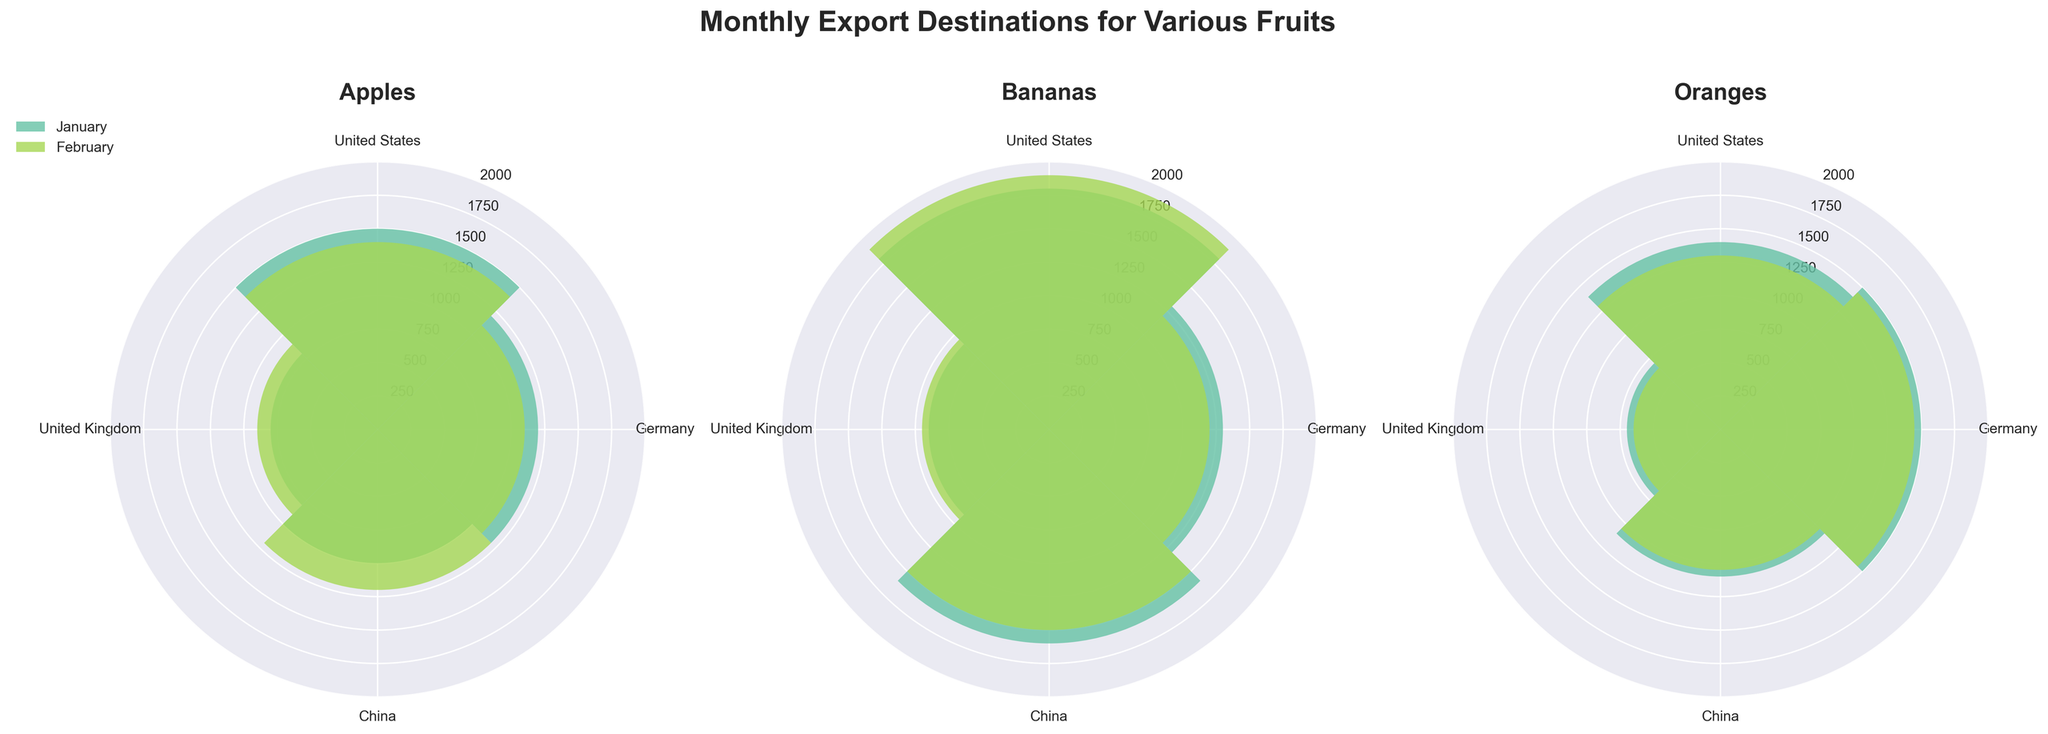What fruit has the highest export quantity to the United States in January? Look at the 'United States' sections of the rose charts for each fruit and compare their heights. Bananas have the tallest bar in the United States section in January.
Answer: Bananas Which export destination received the least amount of oranges in February? Look at the 'Oranges' rose chart and compare the heights of the February bars. The shortest bar is at 'United Kingdom.'
Answer: United Kingdom How does the quantity of apples exported to China change from January to February? Look at the 'Apples' rose chart and compare the length of the bars for China in January and February. January's bar extends to 1000, and February's extends to 1200. The difference is 200 metric tons.
Answer: Increases by 200 metric tons Which month had a higher total export quantity for apples, January or February? Add up the quantities of apples for all destinations in January and February by locating and summing the respective bars. January: 1500 + 1200 + 1000 + 800 = 4500. February: 1400 + 1100 + 1200 + 900 = 4600.
Answer: February Between Germany and the United Kingdom, which received more bananas in January? Compare the height of the bars for 'Bananas' and the export destinations 'Germany' and 'United Kingdom' in January. Germany's bar is taller than the United Kingdom's bar in January.
Answer: Germany What is the average export quantity of oranges to all destinations in February? Look at the 'Oranges' rose chart and find the quantities for February: United States 1300, Germany 1450, China 1050, United Kingdom 650. Sum: 1300+1450+1050+650=4450. Divide by 4: 4450/4 = 1112.5.
Answer: 1112.5 metric tons Which fruit saw the largest increase in export quantity to Germany from January to February? For each fruit, compare the January and February bar heights for Germany and compute the increases. Apples: 900-800=100, Bananas: 950-900=50, Oranges: 1450-1500=-50. The highest positive change is for apples.
Answer: Apples Is there any fruit where the export quantity to all destinations decreased from January to February? Check each fruit's bar height for all destinations between January and February. Oranges show a consistent decrease across all destinations.
Answer: Oranges Which fruit and month combination has the most evenly distributed export quantities across all destinations? Find the fruit and month where the bars for all destinations are of almost equal height. For oranges in February, the lengths (1300, 1450, 1050, 650) exhibit notable discrepancy, making it less even. Bananas in January, with (1800, 1300, 1600, 900), also show disparity. Apples in February with (1400, 1100, 1200, 900) exhibit the least discrepancy.
Answer: Apples in February 